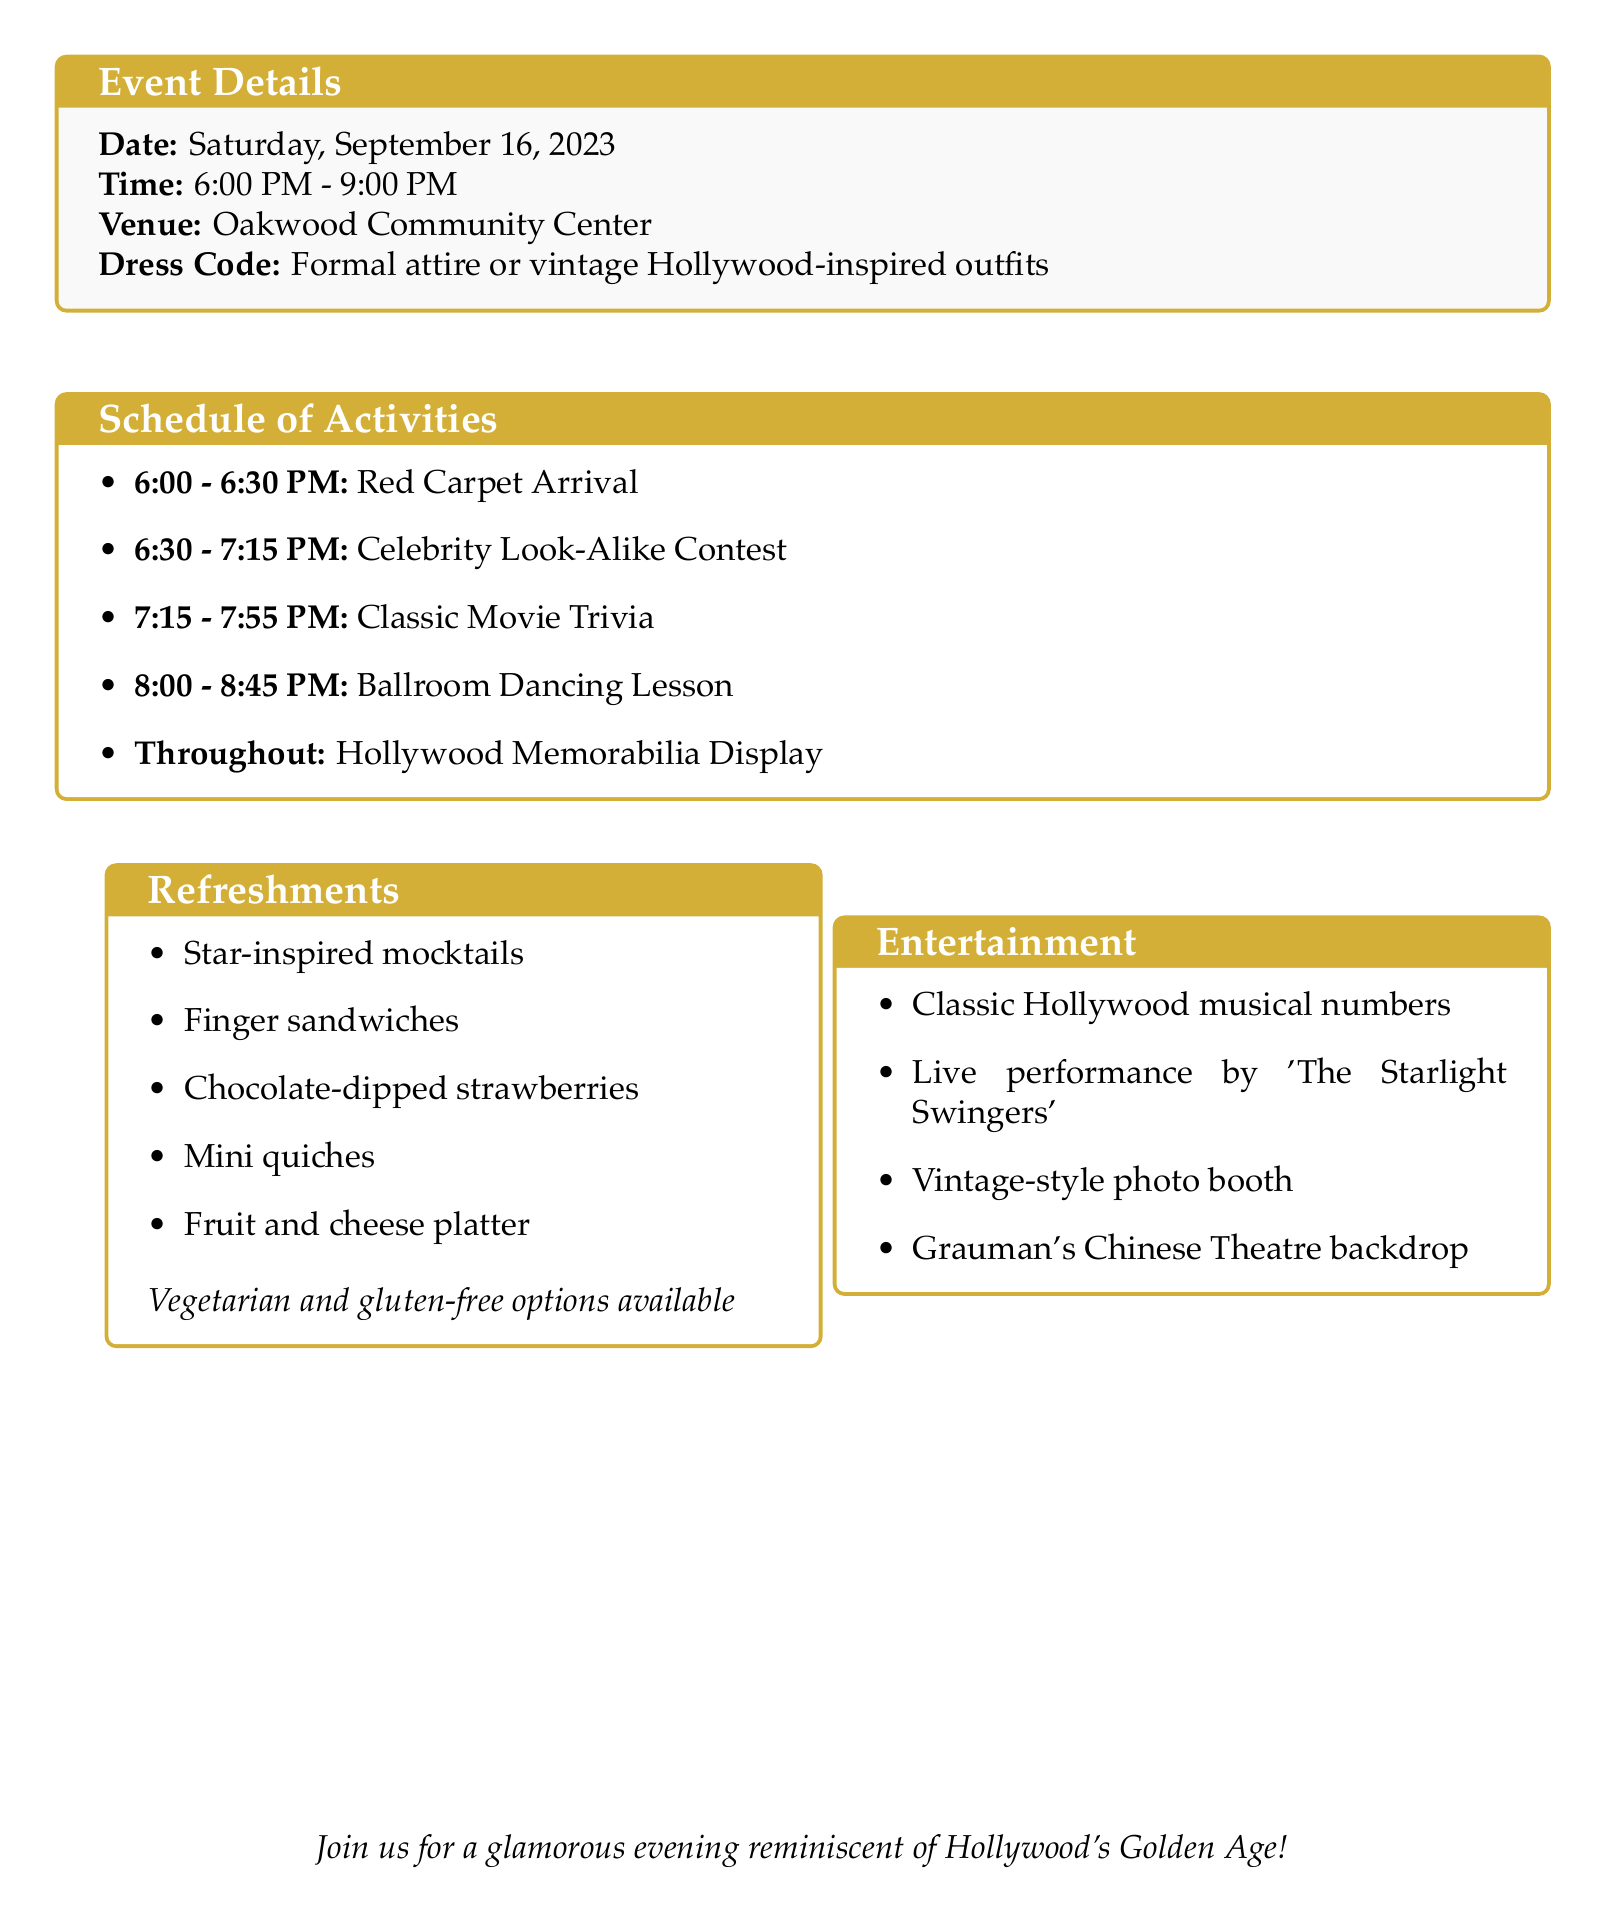What is the event name? The event name is displayed prominently at the top of the document.
Answer: Hollywood Glamour Senior Social What is the date of the event? The date is specified in the event details section.
Answer: Saturday, September 16, 2023 What venue will the event take place in? The venue is listed in the event details box.
Answer: Oakwood Community Center How long is the Celebrity Look-Alike Contest? The duration of this activity is mentioned next to its description.
Answer: 45 minutes What are the prizes for the contest? The prizes are listed under the contest's description.
Answer: Best Marilyn Monroe, Best Clark Gable, Best Audrey Hepburn What dietary options are available? Special diets are mentioned in the refreshments section.
Answer: Vegetarian, Gluten-free options available What type of music will be played during the event? The type of background music is specified in the entertainment section.
Answer: Playlist of classic Hollywood musical numbers and jazz standards What is one of the special considerations for the event? The special considerations are listed to ensure comfort and accessibility.
Answer: Ensure adequate seating and rest areas Who is providing live entertainment? The live performance information is stated in the entertainment section.
Answer: Local swing band 'The Starlight Swingers' 